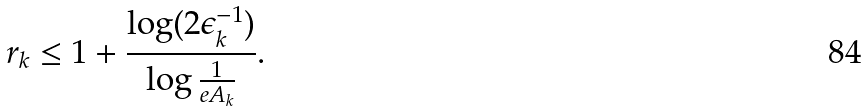Convert formula to latex. <formula><loc_0><loc_0><loc_500><loc_500>r _ { k } \leq 1 + \frac { \log ( 2 \epsilon _ { k } ^ { - 1 } ) } { \log { \frac { 1 } { e A _ { k } } } } .</formula> 